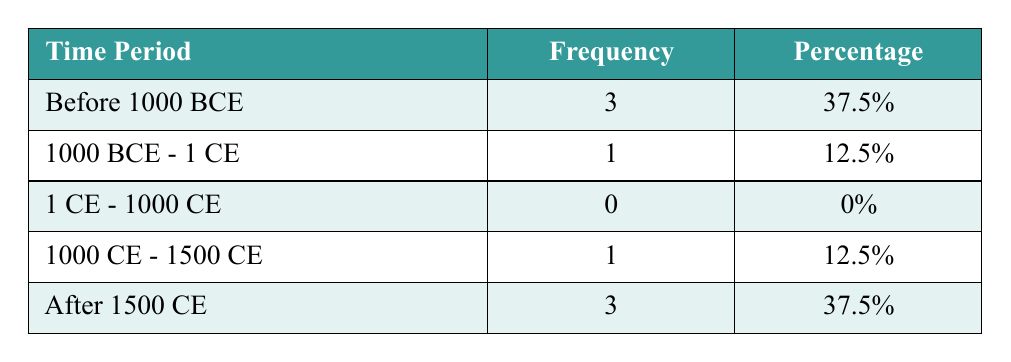What is the frequency of treaties established before 1000 BCE? The table indicates that there are 3 treaties established before 1000 BCE. This value is directly listed in the corresponding row under the "Frequency" column.
Answer: 3 What percentage of treaties fall within the time period after 1500 CE? According to the table, there are 3 treaties established after 1500 CE, which accounts for 37.5% of the total treaties listed. This value is also directly provided in the "Percentage" column.
Answer: 37.5% How many treaties were established between the years 1000 BCE and 1 CE? The table shows that there is 1 treaty established in the period between 1000 BCE and 1 CE. This number is directly found in the corresponding row in the "Frequency" column.
Answer: 1 Is the number of treaties in the period 1 CE - 1000 CE greater than the number in the period 1000 CE - 1500 CE? The table shows 0 treaties in the period 1 CE - 1000 CE and 1 treaty in the period 1000 CE - 1500 CE. Therefore, the statement is false, as 0 is not greater than 1.
Answer: No What is the total number of treaties listed in the table? To find the total number of treaties, we sum the frequencies from all periods: 3 + 1 + 0 + 1 + 3 = 8. Thus, the total number of treaties listed is 8.
Answer: 8 What proportion of treaties were established between 1000 BCE and 1 CE compared to those before 1000 BCE? There is 1 treaty from the period 1000 BCE - 1 CE and 3 treaties from the period before 1000 BCE. The proportion is 1 (from 1000 BCE - 1 CE) to 3 (from before 1000 BCE). This indicates a ratio of 1:3.
Answer: 1:3 How many treaties were established during the period 1000 CE - 1500 CE? The table records 1 treaty established during the period 1000 CE - 1500 CE, which is stated directly in the corresponding row.
Answer: 1 Which period has the highest frequency of treaties established? The period before 1000 BCE and the period after 1500 CE both have the highest frequency, with 3 treaties each. This is observed by comparing the values in the "Frequency" column across all periods.
Answer: Before 1000 BCE and After 1500 CE 